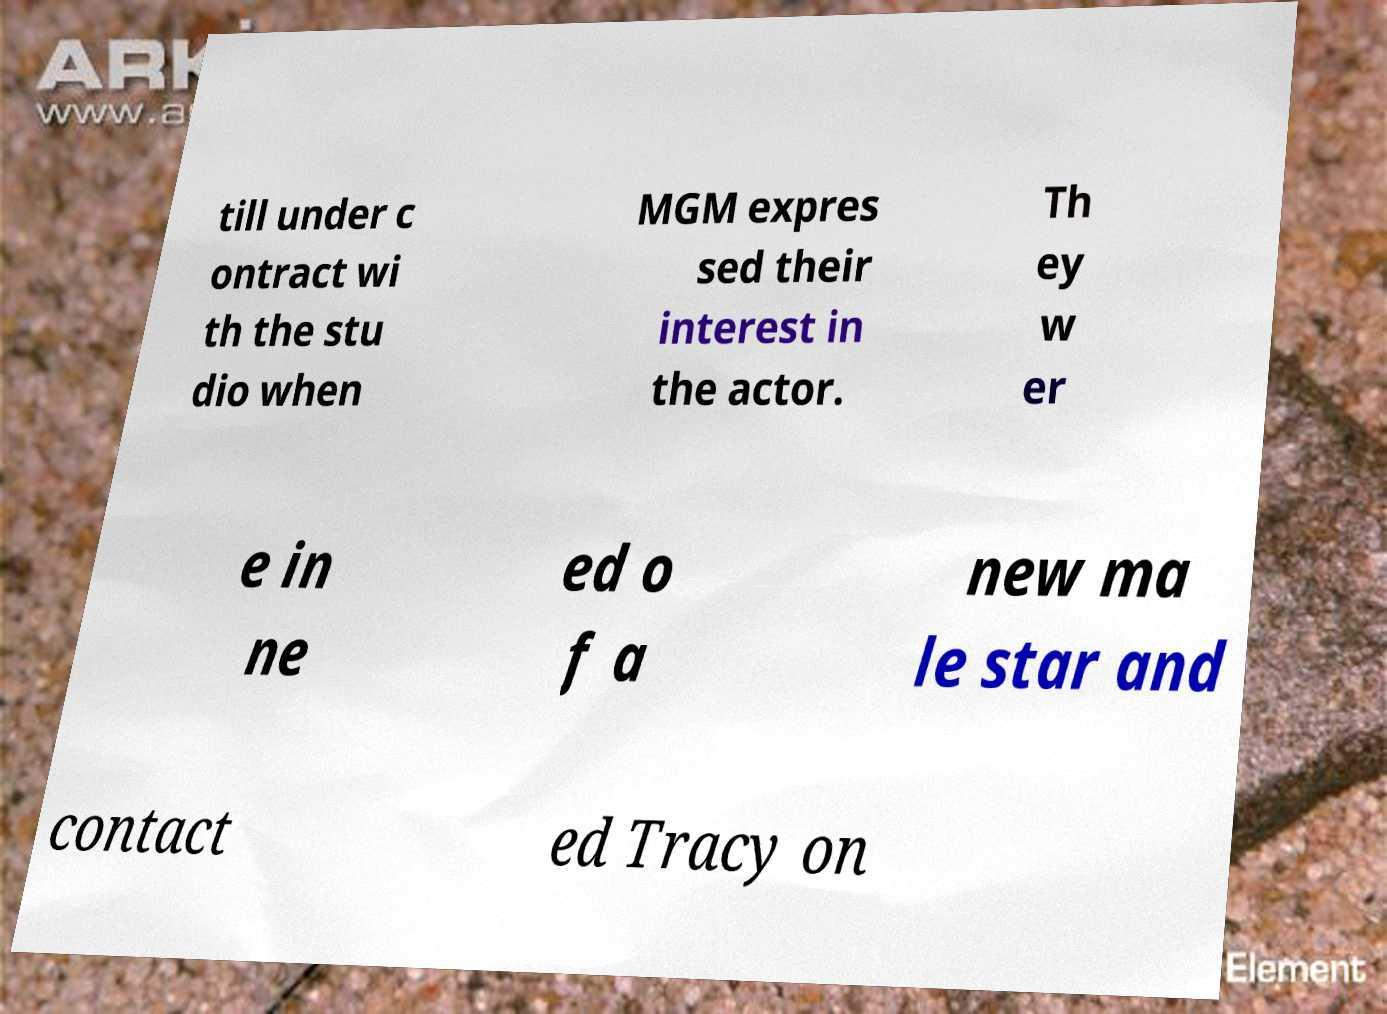Could you extract and type out the text from this image? till under c ontract wi th the stu dio when MGM expres sed their interest in the actor. Th ey w er e in ne ed o f a new ma le star and contact ed Tracy on 